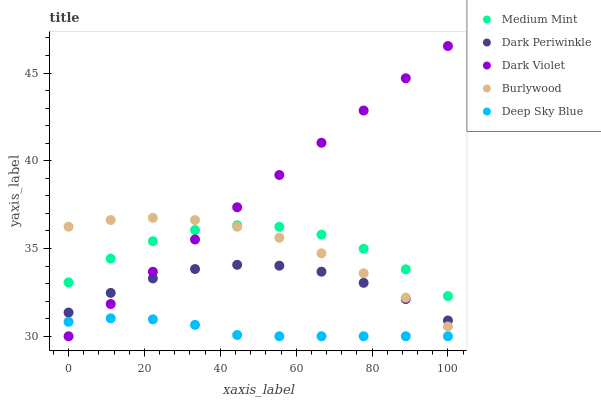Does Deep Sky Blue have the minimum area under the curve?
Answer yes or no. Yes. Does Dark Violet have the maximum area under the curve?
Answer yes or no. Yes. Does Burlywood have the minimum area under the curve?
Answer yes or no. No. Does Burlywood have the maximum area under the curve?
Answer yes or no. No. Is Dark Violet the smoothest?
Answer yes or no. Yes. Is Medium Mint the roughest?
Answer yes or no. Yes. Is Burlywood the smoothest?
Answer yes or no. No. Is Burlywood the roughest?
Answer yes or no. No. Does Dark Violet have the lowest value?
Answer yes or no. Yes. Does Burlywood have the lowest value?
Answer yes or no. No. Does Dark Violet have the highest value?
Answer yes or no. Yes. Does Burlywood have the highest value?
Answer yes or no. No. Is Deep Sky Blue less than Burlywood?
Answer yes or no. Yes. Is Medium Mint greater than Deep Sky Blue?
Answer yes or no. Yes. Does Dark Periwinkle intersect Dark Violet?
Answer yes or no. Yes. Is Dark Periwinkle less than Dark Violet?
Answer yes or no. No. Is Dark Periwinkle greater than Dark Violet?
Answer yes or no. No. Does Deep Sky Blue intersect Burlywood?
Answer yes or no. No. 